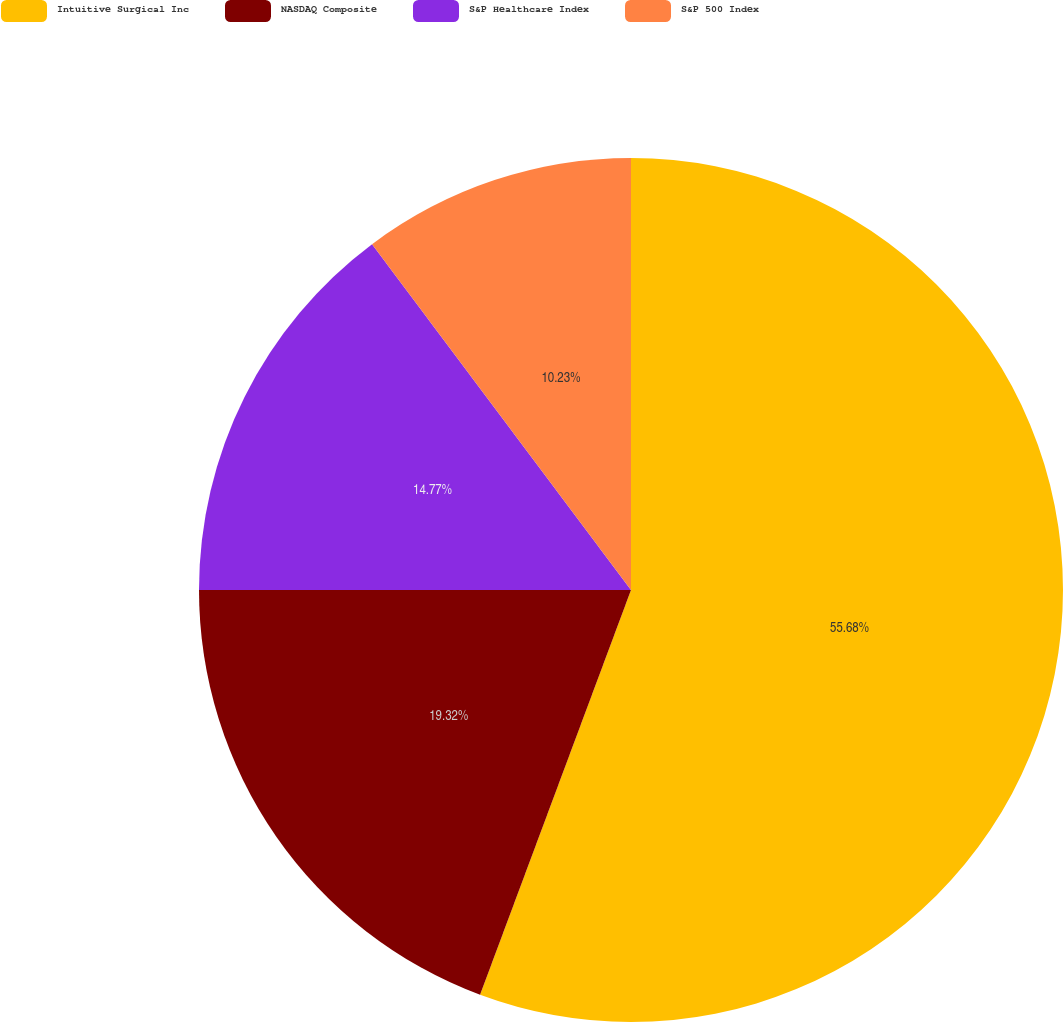Convert chart to OTSL. <chart><loc_0><loc_0><loc_500><loc_500><pie_chart><fcel>Intuitive Surgical Inc<fcel>NASDAQ Composite<fcel>S&P Healthcare Index<fcel>S&P 500 Index<nl><fcel>55.68%<fcel>19.32%<fcel>14.77%<fcel>10.23%<nl></chart> 